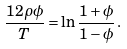Convert formula to latex. <formula><loc_0><loc_0><loc_500><loc_500>\frac { 1 2 \rho \phi } { T } = \ln \frac { 1 + \phi } { 1 - \phi } \, .</formula> 